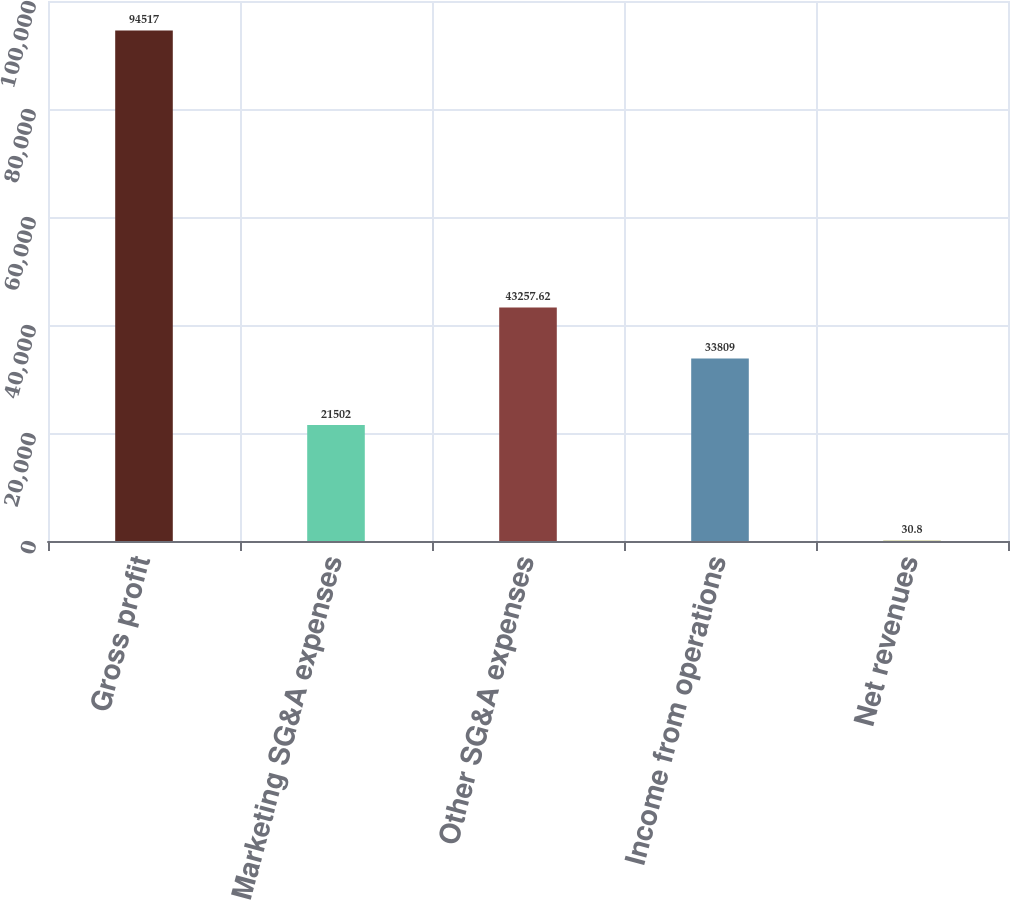Convert chart. <chart><loc_0><loc_0><loc_500><loc_500><bar_chart><fcel>Gross profit<fcel>Marketing SG&A expenses<fcel>Other SG&A expenses<fcel>Income from operations<fcel>Net revenues<nl><fcel>94517<fcel>21502<fcel>43257.6<fcel>33809<fcel>30.8<nl></chart> 